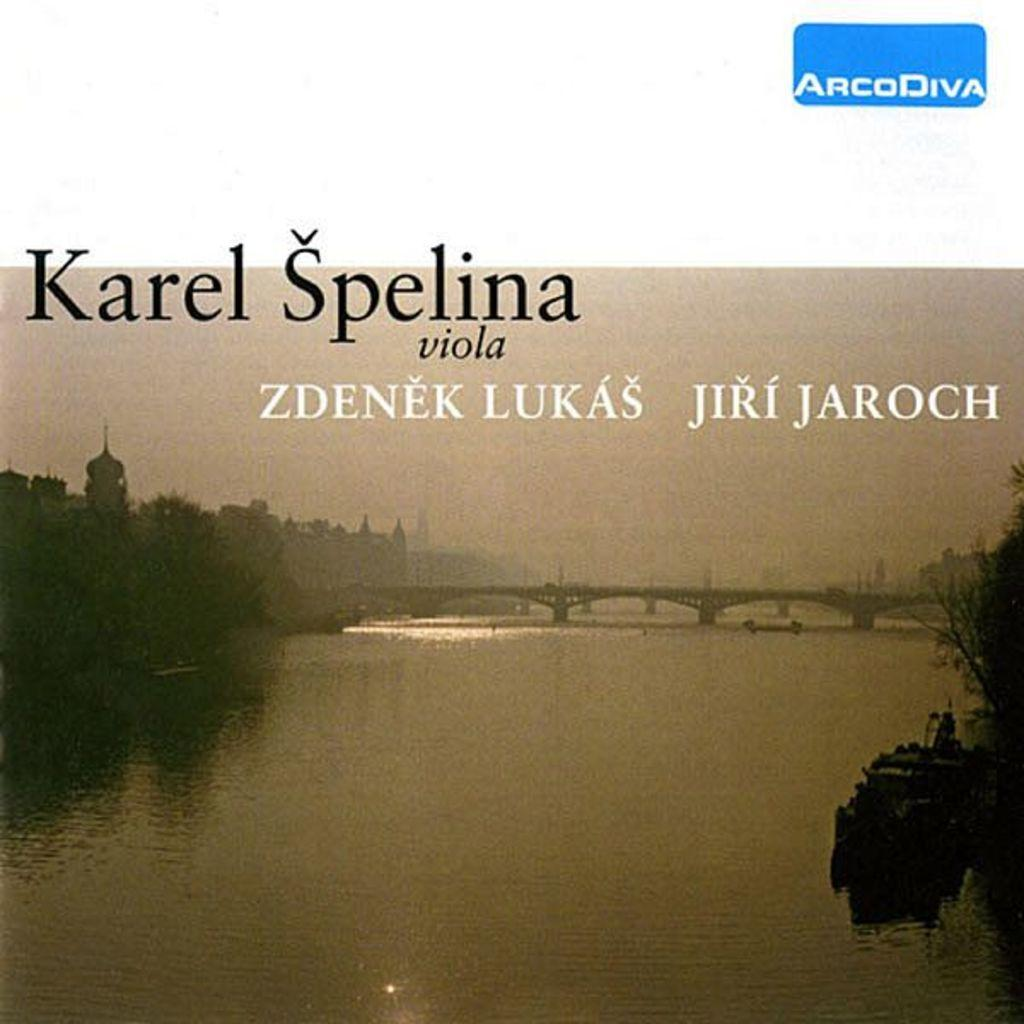What type of structure is present in the image? There is a bridge in the image. What body of water is visible in the image? There is a river in the image. What type of vegetation can be seen in the image? There are trees in the image. What type of man-made structures are present in the image? There are buildings in the image. What type of transportation can be seen in the image? There are boats in the image. What part of the natural environment is visible in the image? The sky is visible in the image. What language is spoken by the gate in the image? There is no gate present in the image, and therefore no language can be attributed to it. What type of mouth is visible on the trees in the image? There are no mouths present on the trees in the image; they are simply trees. 